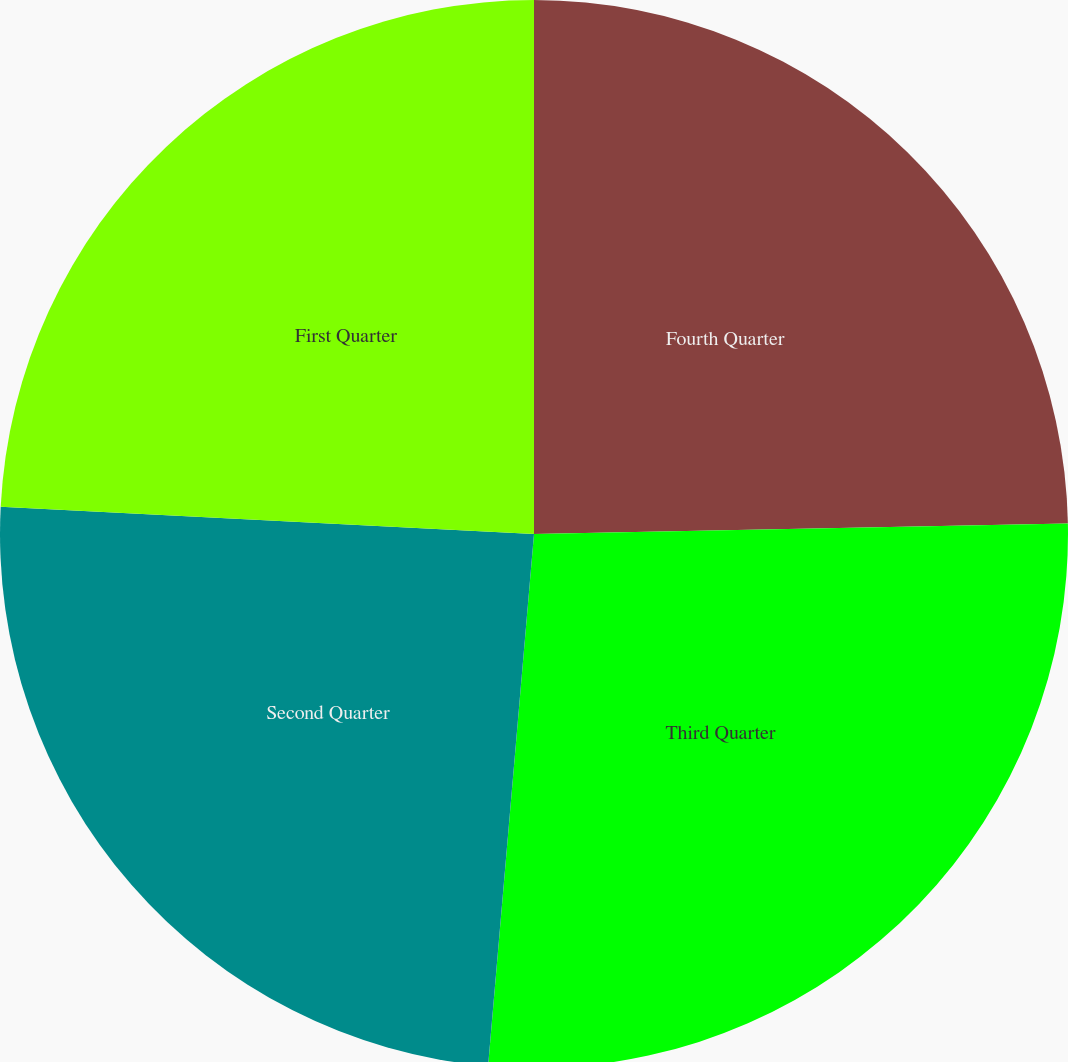Convert chart. <chart><loc_0><loc_0><loc_500><loc_500><pie_chart><fcel>Fourth Quarter<fcel>Third Quarter<fcel>Second Quarter<fcel>First Quarter<nl><fcel>24.69%<fcel>26.68%<fcel>24.44%<fcel>24.19%<nl></chart> 